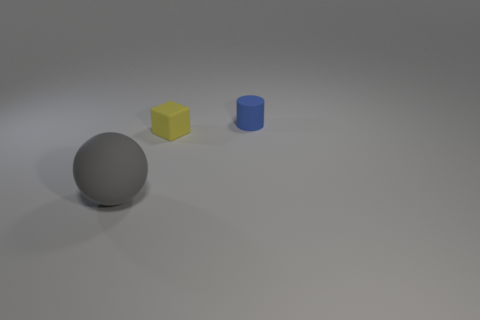Add 1 gray rubber balls. How many objects exist? 4 Subtract all balls. How many objects are left? 2 Subtract 0 green cylinders. How many objects are left? 3 Subtract all large gray cylinders. Subtract all yellow matte things. How many objects are left? 2 Add 2 blue cylinders. How many blue cylinders are left? 3 Add 1 gray spheres. How many gray spheres exist? 2 